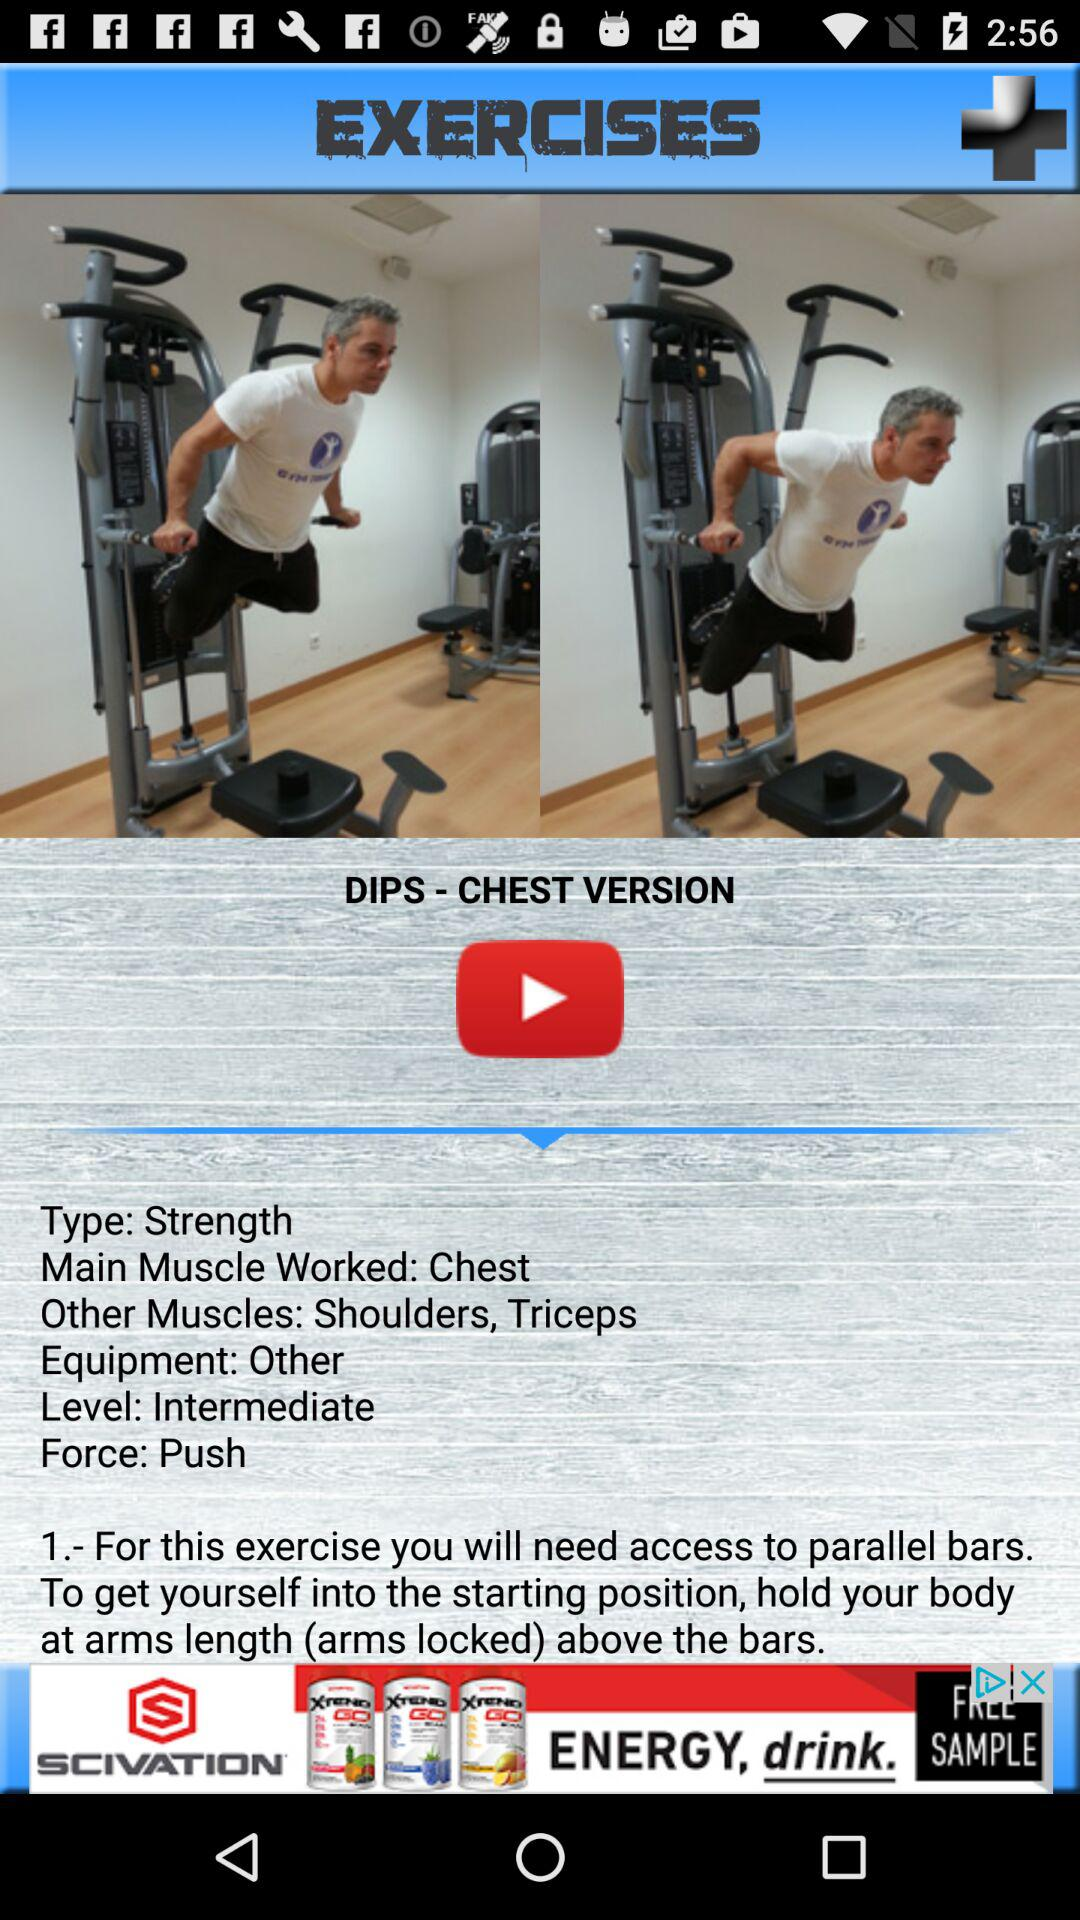What is the name of the equipment? The name of the equipment is "parallel bars". 